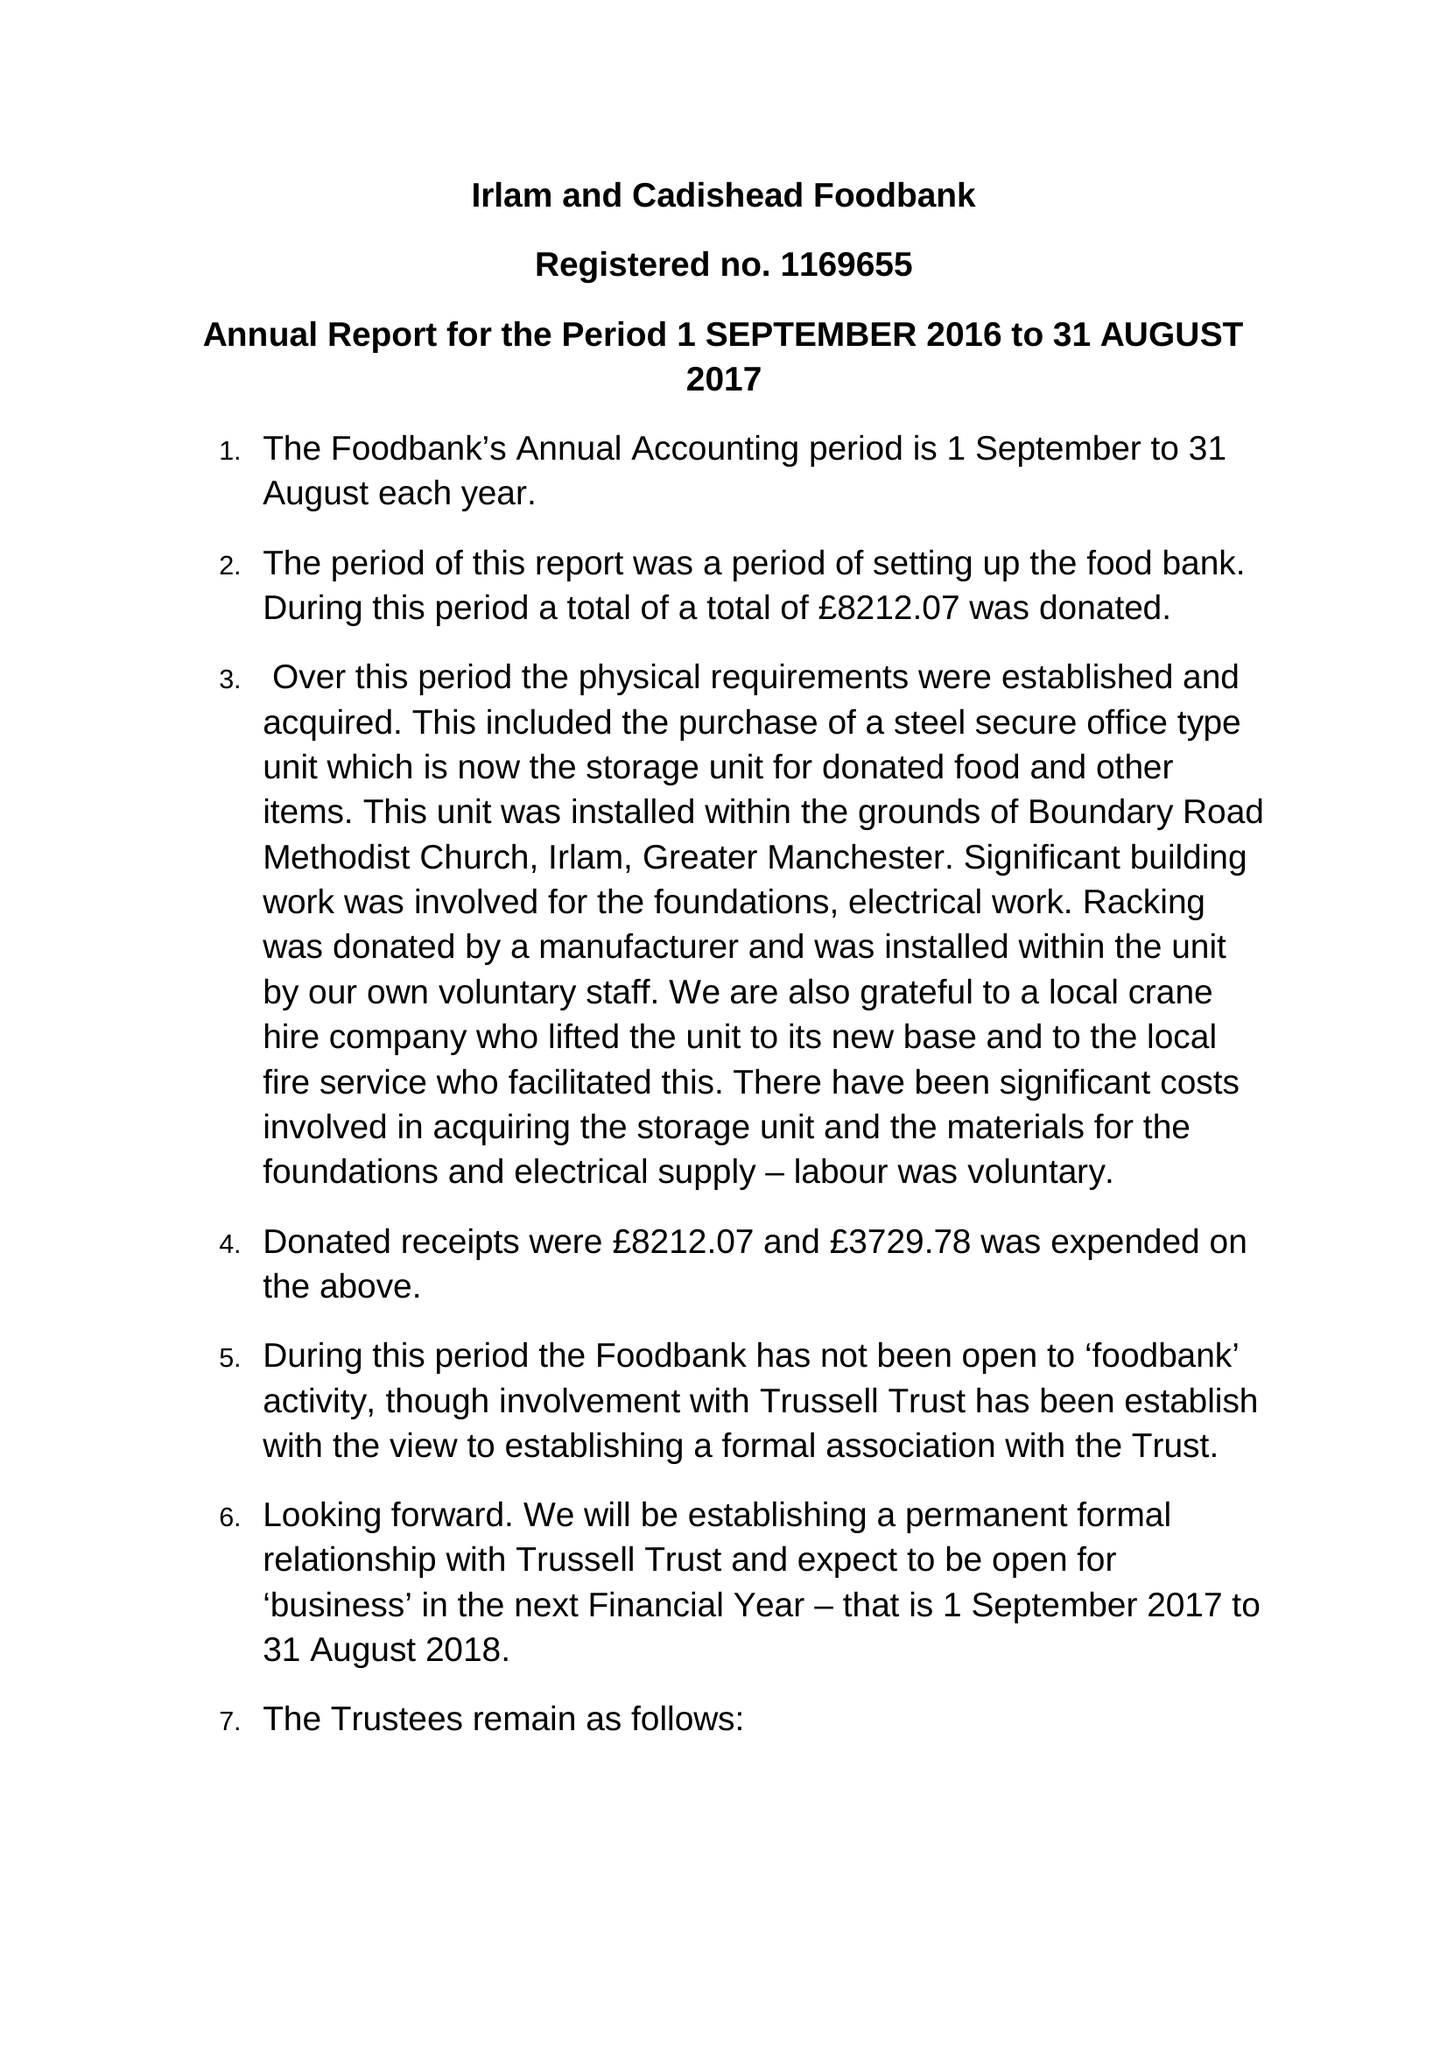What is the value for the income_annually_in_british_pounds?
Answer the question using a single word or phrase. 8212.00 